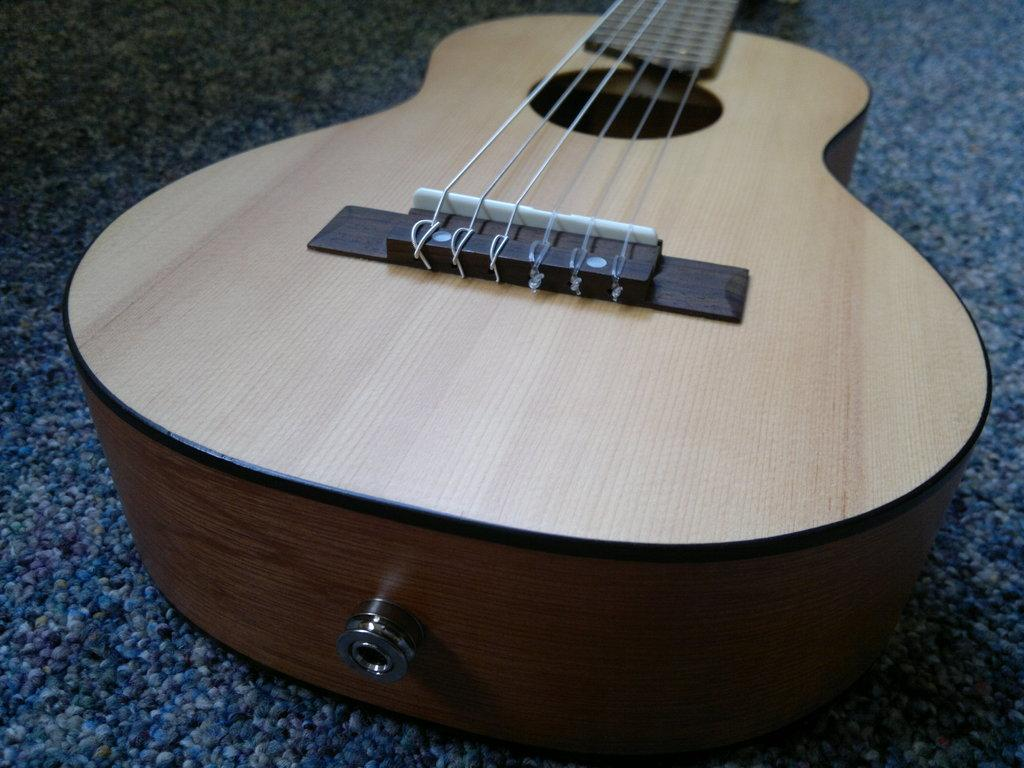What type of musical instrument is shown in the image? The object is a guitar, which is a musical instrument. What type of lettuce is used to decorate the guitar in the image? There is no lettuce present in the image, as it features a guitar, which is a musical instrument. 